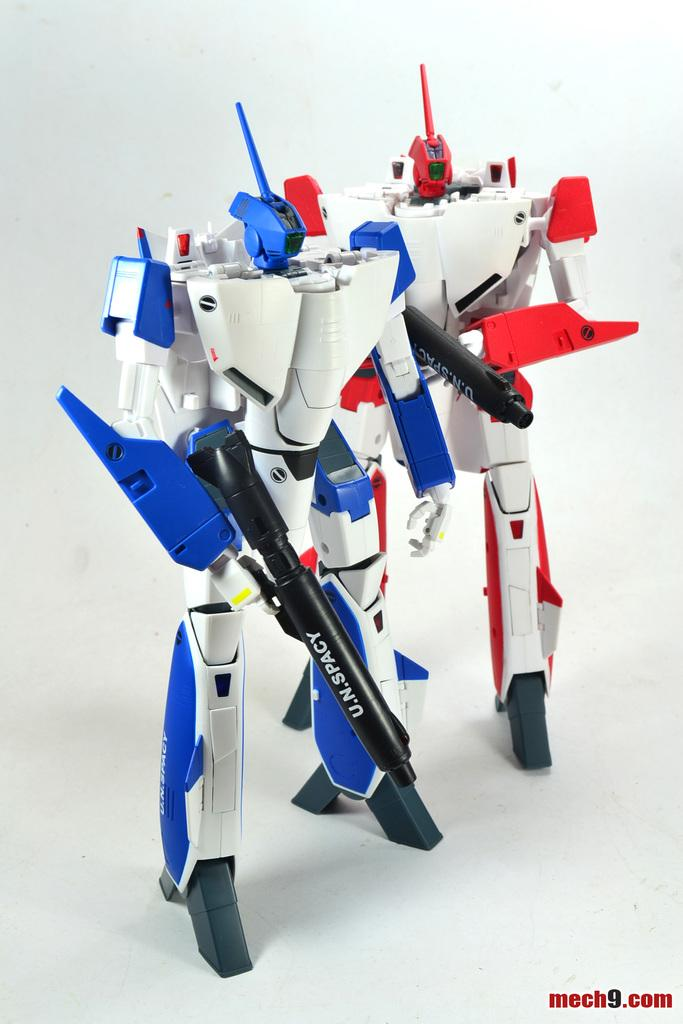How many toys are present in the image? There are two toys in the image. What is the color of the surface on which the toys are placed? The toys are on a white color surface. What colors can be seen on the toys? The toys have white, blue, and red colors. What is the color of the background in the image? The background of the image is white. Is the girl wearing a vest in the image? There is no girl present in the image, so it is not possible to determine if she is wearing a vest. 